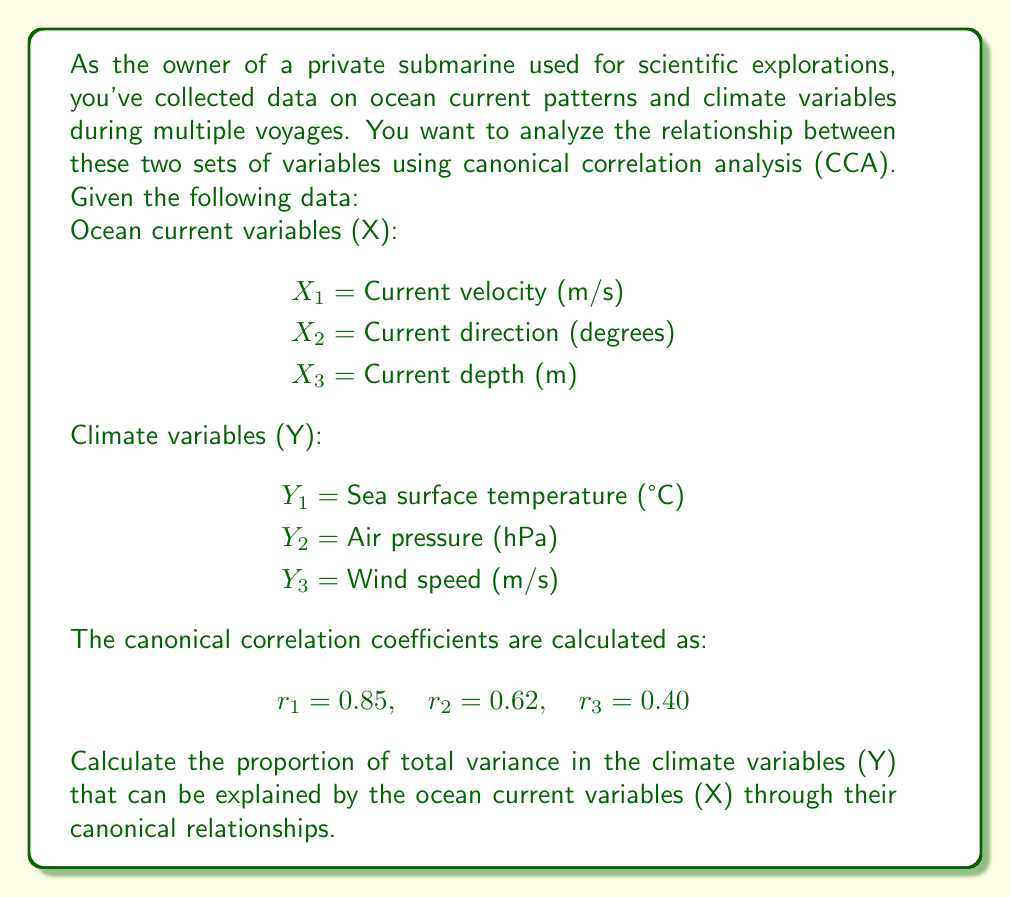Solve this math problem. To solve this problem, we need to use the concept of redundancy in canonical correlation analysis. The redundancy index measures the amount of variance in one set of variables that can be explained by the other set through their canonical relationships.

Step 1: Calculate the average squared canonical correlation.
The average squared canonical correlation is given by:

$$ \text{Average } r^2 = \frac{\sum_{i=1}^p r_i^2}{p} $$

where $p$ is the number of canonical correlations (in this case, 3).

$$ \text{Average } r^2 = \frac{0.85^2 + 0.62^2 + 0.40^2}{3} = \frac{0.7225 + 0.3844 + 0.1600}{3} = 0.4223 $$

Step 2: Calculate the redundancy index.
The redundancy index for Y given X is:

$$ \text{Redundancy}_Y = \text{Average } r^2 \times p $$

where $p$ is the number of variables in the Y set (which is also 3 in this case).

$$ \text{Redundancy}_Y = 0.4223 \times 3 = 1.2669 $$

Step 3: Convert the redundancy index to a proportion.
Since the redundancy index can exceed 1, we need to convert it to a proportion by dividing it by the number of Y variables:

$$ \text{Proportion of variance explained} = \frac{\text{Redundancy}_Y}{p} = \frac{1.2669}{3} = 0.4223 $$

Therefore, approximately 42.23% of the total variance in the climate variables (Y) can be explained by the ocean current variables (X) through their canonical relationships.
Answer: The proportion of total variance in the climate variables (Y) that can be explained by the ocean current variables (X) through their canonical relationships is 0.4223 or 42.23%. 